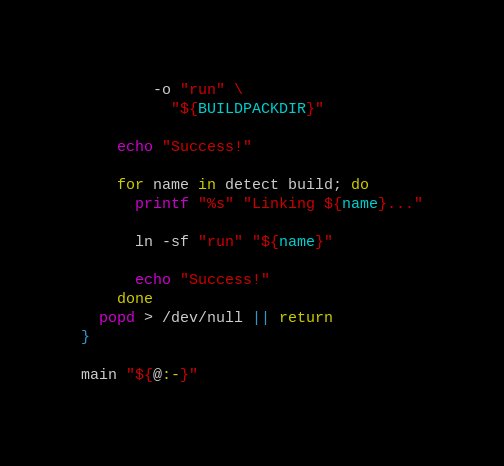Convert code to text. <code><loc_0><loc_0><loc_500><loc_500><_Bash_>        -o "run" \
          "${BUILDPACKDIR}"

    echo "Success!"

    for name in detect build; do
      printf "%s" "Linking ${name}..."

      ln -sf "run" "${name}"

      echo "Success!"
    done
  popd > /dev/null || return
}

main "${@:-}"
</code> 